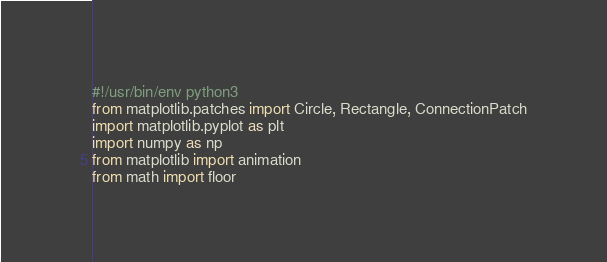<code> <loc_0><loc_0><loc_500><loc_500><_Python_>#!/usr/bin/env python3
from matplotlib.patches import Circle, Rectangle, ConnectionPatch
import matplotlib.pyplot as plt
import numpy as np
from matplotlib import animation
from math import floor
</code> 